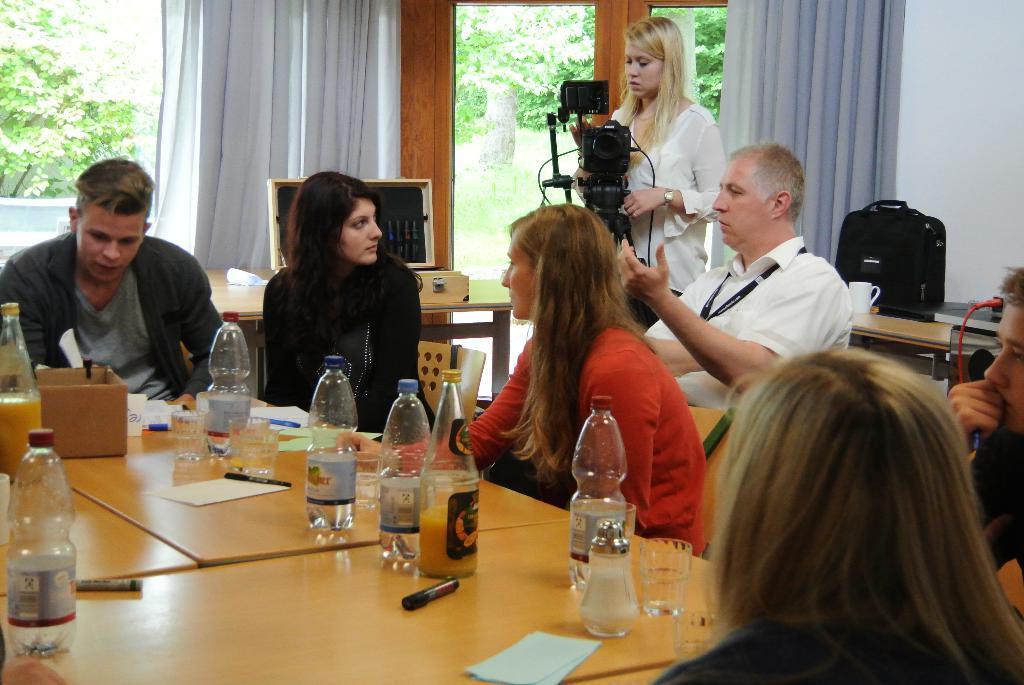Could you give a brief overview of what you see in this image? In this image there are few persons sitting on the chair before a table having few bottles, glasses, papers and pens on it. A person wearing a white shirt is sitting on chair beside a camera stand. A woman wearing a white top is standing behind the stand. There is a table having a bag and a cup on it. There are few windows covered with curtain. From windows few trees are visible. 